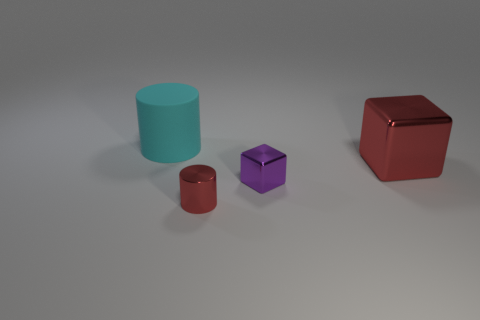Do the small cube and the large cyan cylinder have the same material?
Keep it short and to the point. No. Are there fewer tiny red metal things than big gray rubber objects?
Your answer should be very brief. No. Is the shape of the purple shiny thing the same as the big red metal object?
Offer a terse response. Yes. The large cube has what color?
Ensure brevity in your answer.  Red. What number of other things are there of the same material as the big red cube
Your answer should be very brief. 2. What number of gray things are metallic blocks or tiny blocks?
Ensure brevity in your answer.  0. There is a large object in front of the rubber cylinder; does it have the same shape as the big rubber object left of the tiny cube?
Make the answer very short. No. There is a tiny metallic cylinder; is it the same color as the metallic block to the right of the purple metallic cube?
Ensure brevity in your answer.  Yes. Is the color of the thing behind the red cube the same as the tiny shiny cylinder?
Keep it short and to the point. No. What number of things are either big red blocks or purple metallic blocks that are in front of the big red shiny object?
Keep it short and to the point. 2. 